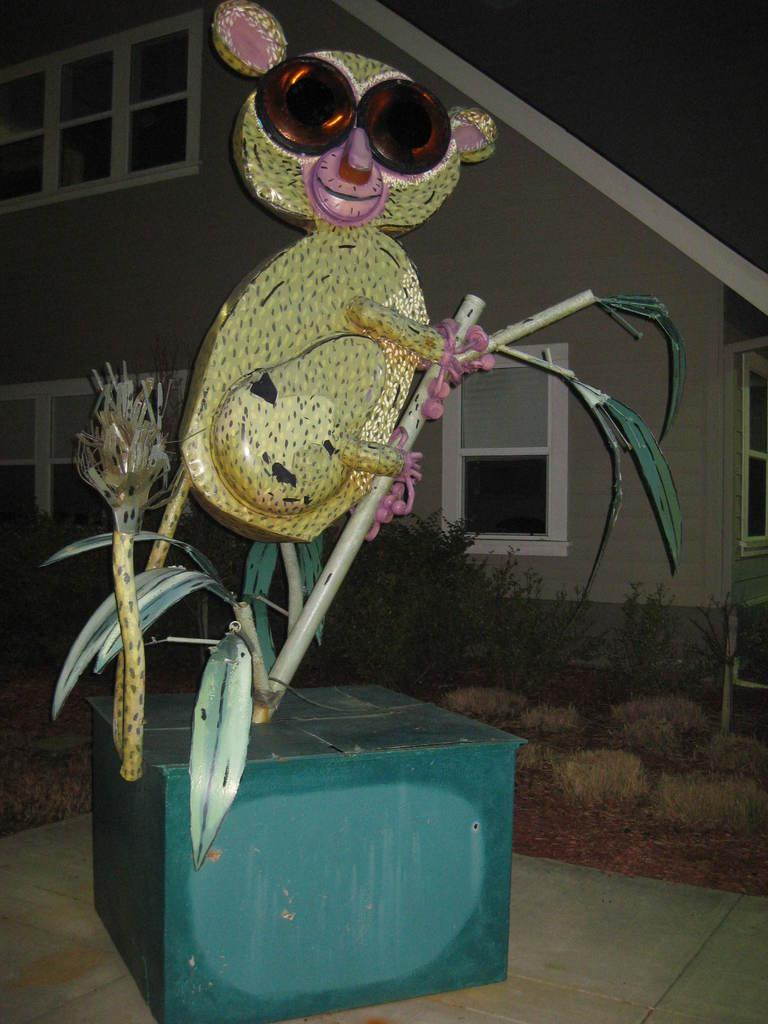What is on top of the green color box in the image? There is an animal's statue on a green color box in the image. Where is the green color box located? The green color box is on the floor. What can be seen in the background of the image? There are stones, plants, and a building with glass windows in the background. What type of chairs are being discussed in the image? There is no discussion about chairs in the image, as the focus is on the animal's statue and the green color box. 